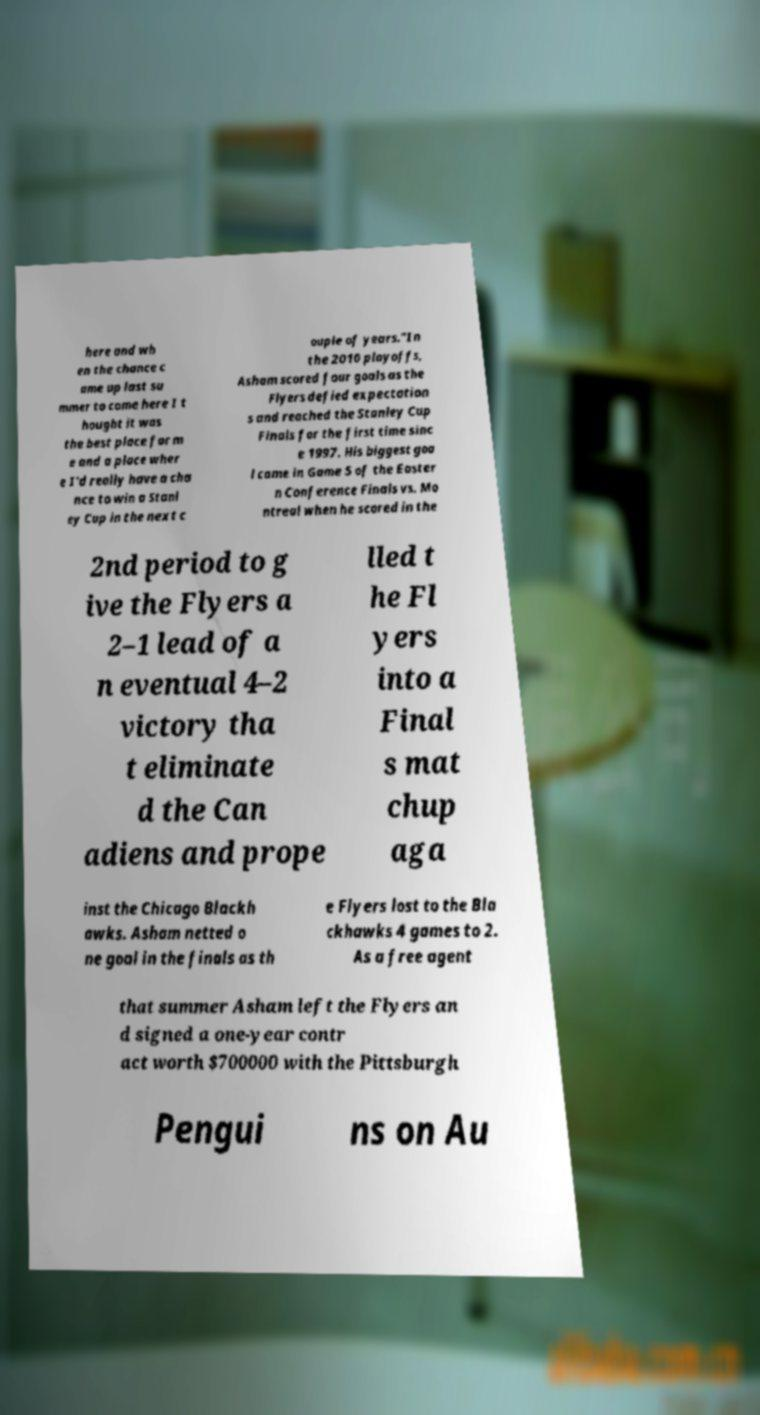What messages or text are displayed in this image? I need them in a readable, typed format. here and wh en the chance c ame up last su mmer to come here I t hought it was the best place for m e and a place wher e I'd really have a cha nce to win a Stanl ey Cup in the next c ouple of years."In the 2010 playoffs, Asham scored four goals as the Flyers defied expectation s and reached the Stanley Cup Finals for the first time sinc e 1997. His biggest goa l came in Game 5 of the Easter n Conference Finals vs. Mo ntreal when he scored in the 2nd period to g ive the Flyers a 2–1 lead of a n eventual 4–2 victory tha t eliminate d the Can adiens and prope lled t he Fl yers into a Final s mat chup aga inst the Chicago Blackh awks. Asham netted o ne goal in the finals as th e Flyers lost to the Bla ckhawks 4 games to 2. As a free agent that summer Asham left the Flyers an d signed a one-year contr act worth $700000 with the Pittsburgh Pengui ns on Au 